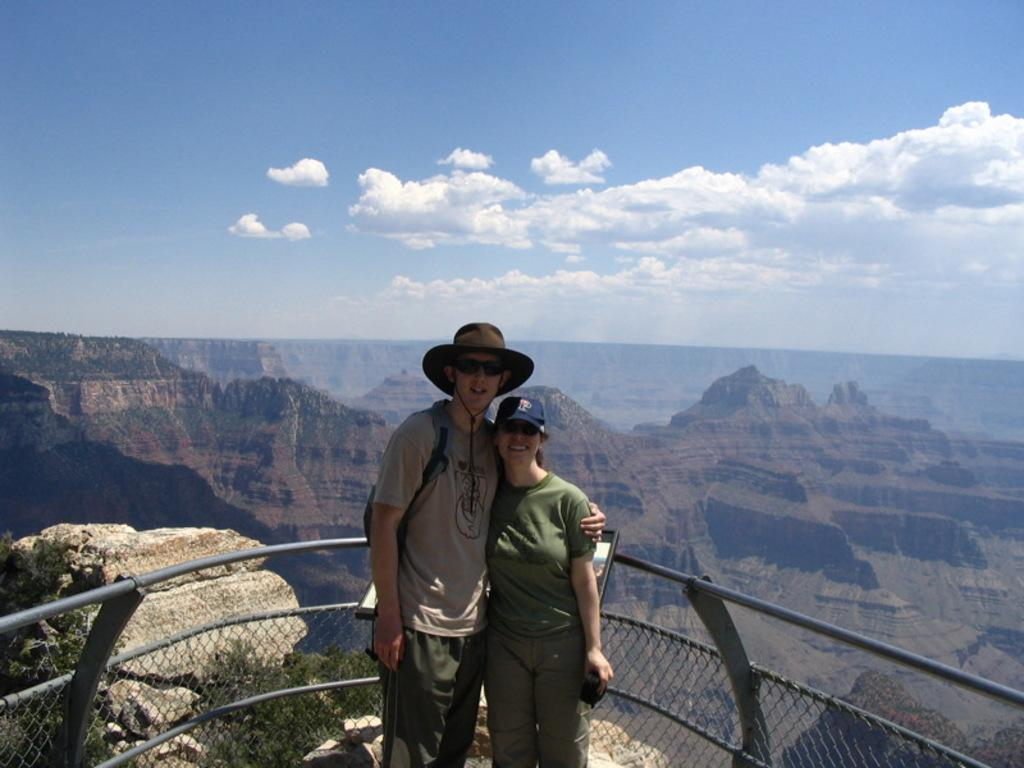Who are the people in the image? There is a man and a woman in the image. What are they doing in front of the fence? They are taking pictures. What can be seen in the background of the image? There are hills visible in the background. What type of zephyr is being recorded by the man and woman in the image? There is no mention of a zephyr in the image, and the man and woman are taking pictures, not recording anything. 